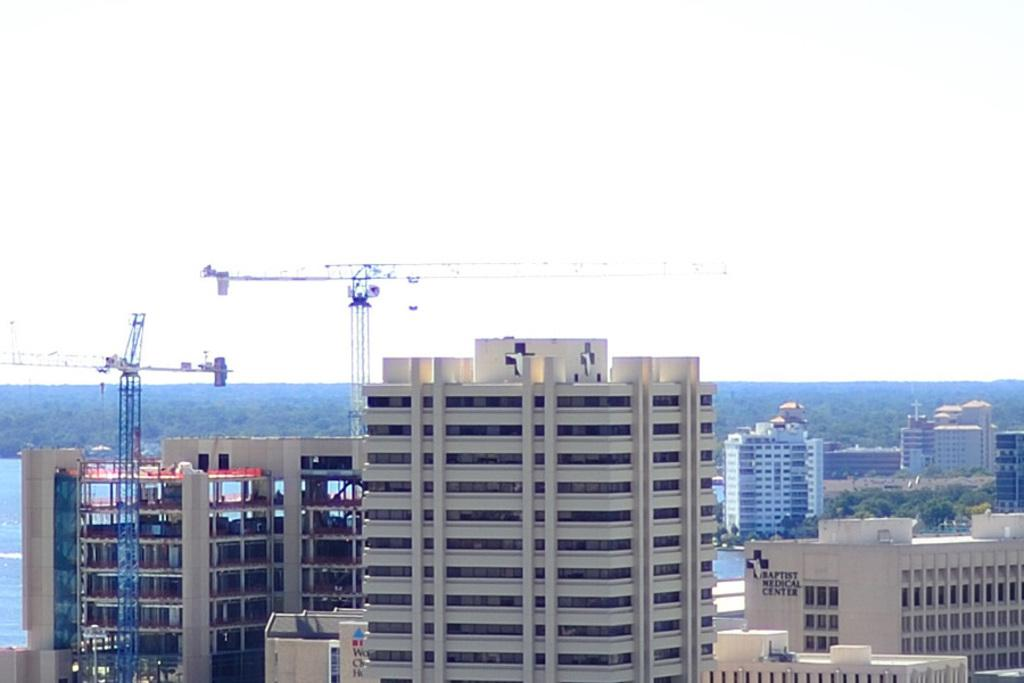What type of structures can be seen in the image? There are buildings in the image. What other natural elements are present in the image? There are trees in the image. What construction equipment can be seen in the image? There are tower cranes in the image. What is visible in the background of the image? The sky is visible in the background of the image. What type of tooth is being used to hold up the tent in the image? There is no tent or tooth present in the image. What idea is being conveyed by the tooth in the image? There is no tooth or idea present in the image. 